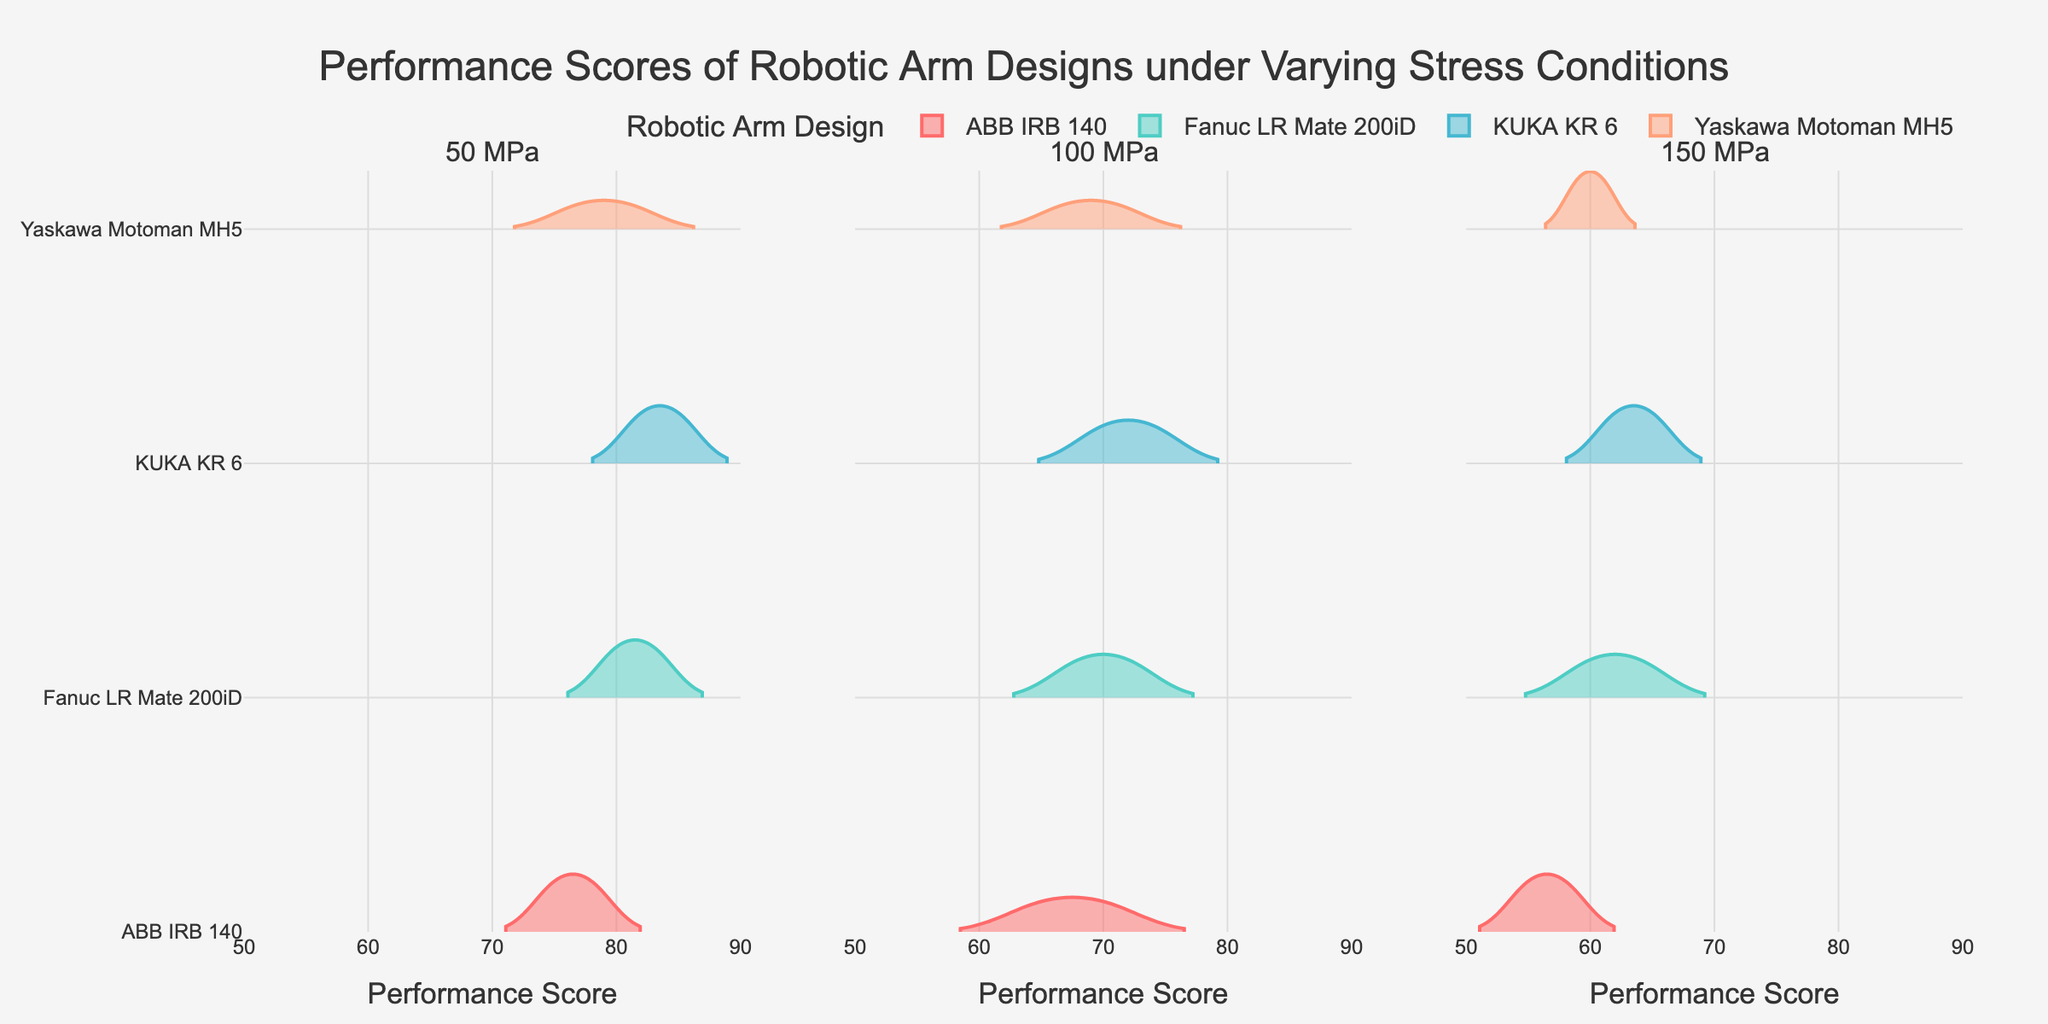What is the title of the figure? The title is typically displayed prominently at the top of the figure. Here, the title found at the top states "Performance Scores of Robotic Arm Designs under Varying Stress Conditions".
Answer: Performance Scores of Robotic Arm Designs under Varying Stress Conditions How many separate subplots are there in the figure? The subplots are created for each stress level category, which can be identified by reading the subplot titles at the top of each plot. Counting them, there are three in total: "50 MPa", "100 MPa", and "150 MPa".
Answer: 3 What color represents the Fanuc LR Mate 200iD design? Each robot design is assigned a unique color for distinction. Observing the legend at the bottom or examining the colored violin plots, the Fanuc LR Mate 200iD is represented by a light blue color.
Answer: Light blue For the KUKA KR 6 design, what is the range of performance scores at 100 MPa stress level? To determine this, observe the KUKA KR 6's violin plot under the 100 MPa subplot. The range is defined by the spread of the violin plot along the x-axis, which spans from 70 to 74.
Answer: 70 to 74 Which robotic arm design appears to perform best under the lowest stress condition (50 MPa)? To find this, compare the median or central values of the violin plots in the 50 MPa subplot. The KUKA KR 6 design has the highest median performance score, indicated by its central mark being the highest along the x-axis.
Answer: KUKA KR 6 What is the overall trend in performance scores as stress level increases for the Yaskawa Motoman MH5 design? Look at each subplot for the Yaskawa Motoman MH5 and observe the central location of their violin plots. The performance scores decrease as stress levels increase: from around 79 at 50 MPa to about 67 at 100 MPa and around 60 at 150 MPa.
Answer: Decreasing Compare the performance scores of ABB IRB 140 and Fanuc LR Mate 200iD at 150 MPa. Which design shows higher performance? Compare the central values of the violin plots for ABB IRB 140 and Fanuc LR Mate 200iD in the 150 MPa subplot. Fanuc LR Mate 200iD has higher median performance scores than ABB IRB 140.
Answer: Fanuc LR Mate 200iD What is the median performance score for the ABB IRB 140 at 100 MPa? The median of the violin plot can be seen around the center of the distribution. For ABB IRB 140 at 100 MPa, the median performance score is approximately 67.5, which is between the marks at 65 and 70 on the x-axis.
Answer: 67.5 Which robotic arm design exhibits the least variance in performance scores at the highest stress level (150 MPa)? To determine variance, the width of the violin plots should be compared. The plot having the narrowest width will indicate the least variance. In this case, the KUKA KR 6 exhibits the least variance at 150 MPa.
Answer: KUKA KR 6 